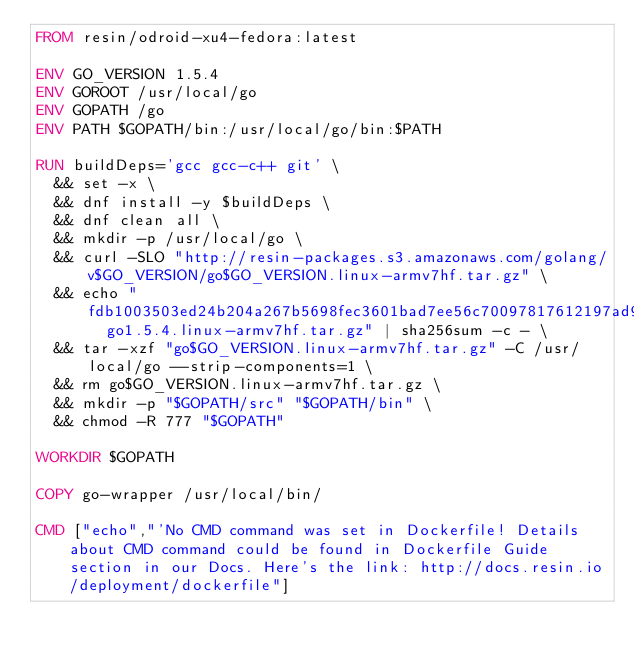Convert code to text. <code><loc_0><loc_0><loc_500><loc_500><_Dockerfile_>FROM resin/odroid-xu4-fedora:latest

ENV GO_VERSION 1.5.4
ENV GOROOT /usr/local/go
ENV GOPATH /go
ENV PATH $GOPATH/bin:/usr/local/go/bin:$PATH

RUN buildDeps='gcc gcc-c++ git' \
	&& set -x \
	&& dnf install -y $buildDeps \
	&& dnf clean all \
	&& mkdir -p /usr/local/go \
	&& curl -SLO "http://resin-packages.s3.amazonaws.com/golang/v$GO_VERSION/go$GO_VERSION.linux-armv7hf.tar.gz" \
	&& echo "fdb1003503ed24b204a267b5698fec3601bad7ee56c70097817612197ad90a8d  go1.5.4.linux-armv7hf.tar.gz" | sha256sum -c - \
	&& tar -xzf "go$GO_VERSION.linux-armv7hf.tar.gz" -C /usr/local/go --strip-components=1 \
	&& rm go$GO_VERSION.linux-armv7hf.tar.gz \
	&& mkdir -p "$GOPATH/src" "$GOPATH/bin" \
	&& chmod -R 777 "$GOPATH"

WORKDIR $GOPATH

COPY go-wrapper /usr/local/bin/

CMD ["echo","'No CMD command was set in Dockerfile! Details about CMD command could be found in Dockerfile Guide section in our Docs. Here's the link: http://docs.resin.io/deployment/dockerfile"]
</code> 